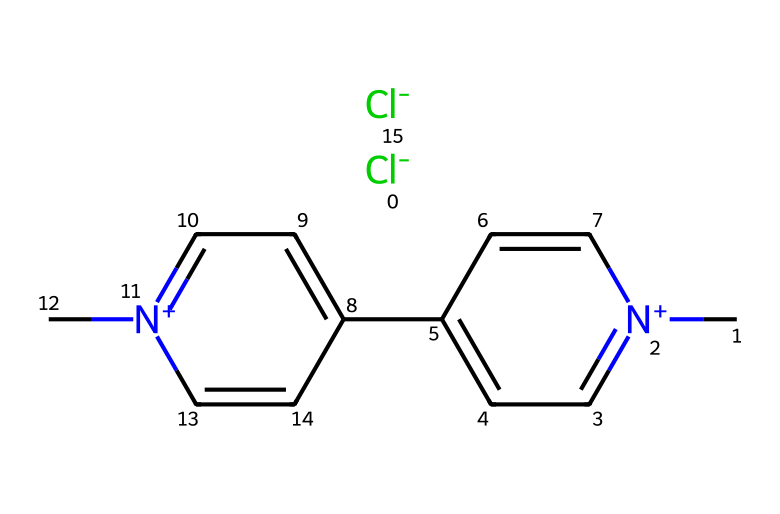What is the molecular formula of paraquat? To determine the molecular formula, we analyze the SMILES representation to count the atoms present: Carbon (C), Hydrogen (H), Chlorine (Cl), and Nitrogen (N). Counting reveals there are 10 Carbons, 12 Hydrogens, 2 Chlorines, and 2 Nitrogens. Therefore, the molecular formula is C10H12Cl2N2.
Answer: C10H12Cl2N2 How many nitrogen atoms are in paraquat? By examining the SMILES representation, we identify the nitrogen atoms marked as [n+] and count them directly. There are two instances of nitrogen, indicating there are 2 nitrogen atoms in the structure.
Answer: 2 What type of herbicide is paraquat classified as? Paraquat is classified as a non-selective herbicide, meaning it kills a wide variety of plants rather than targeting specific types. This classification is based on its chemical structure and mode of action.
Answer: non-selective What is the charge on the nitrogen atoms in paraquat? The notation [n+] in the SMILES structure denotes that the nitrogen atoms have a positive charge. This specification indicates that the nitrogen atoms are protonated, which contributes to the herbicide's reactivity and toxicity.
Answer: positive Which element in paraquat is represented by the [Cl-] notation? The [Cl-] notation in the SMILES indicates that Chlorine is present as a negatively charged ion (chloride ion). This reveals the chlorine's role in the molecular structure and charge balance of paraquat.
Answer: Chlorine How many rings are present in the molecular structure of paraquat? Analyzing the structure from the SMILES, we look for cyclic arrangements. The presence of 'c' in the notation indicates aromatic rings. Counting the instances of connecting 'c' shows there are two fused aromatic rings in paraquat.
Answer: 2 What functional group is prominent in paraquat's structure? Noting the presence of nitrogen atoms and their connection to aromatic frameworks, we conclude that the molecule contains an aromatic amine functional group, characterized by a nitrogen atom connected to a carbon in an aromatic ring.
Answer: aromatic amine 